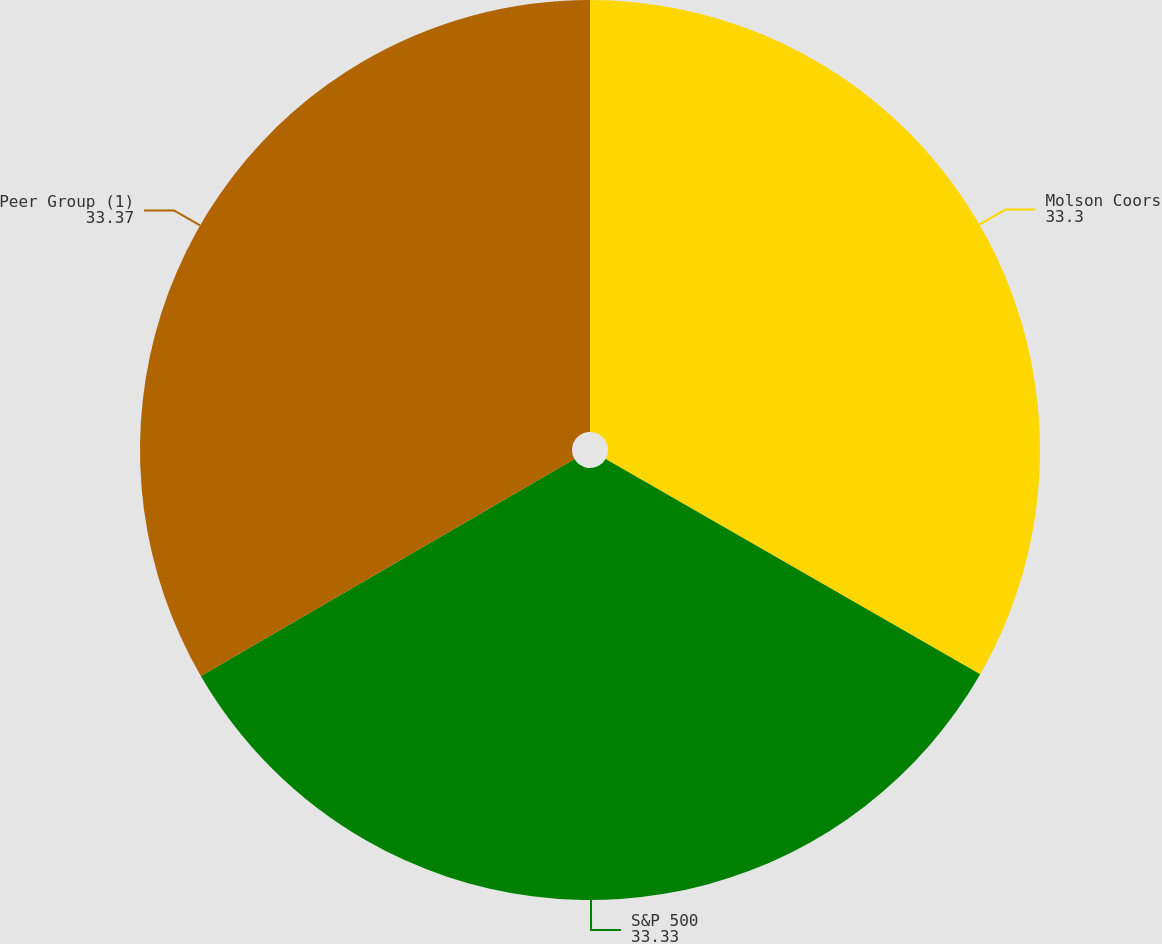Convert chart. <chart><loc_0><loc_0><loc_500><loc_500><pie_chart><fcel>Molson Coors<fcel>S&P 500<fcel>Peer Group (1)<nl><fcel>33.3%<fcel>33.33%<fcel>33.37%<nl></chart> 